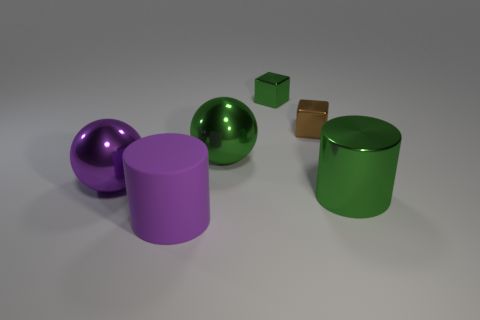Add 1 tiny gray metal spheres. How many objects exist? 7 Subtract all large purple shiny cubes. Subtract all tiny things. How many objects are left? 4 Add 3 shiny objects. How many shiny objects are left? 8 Add 3 green spheres. How many green spheres exist? 4 Subtract 0 cyan cubes. How many objects are left? 6 